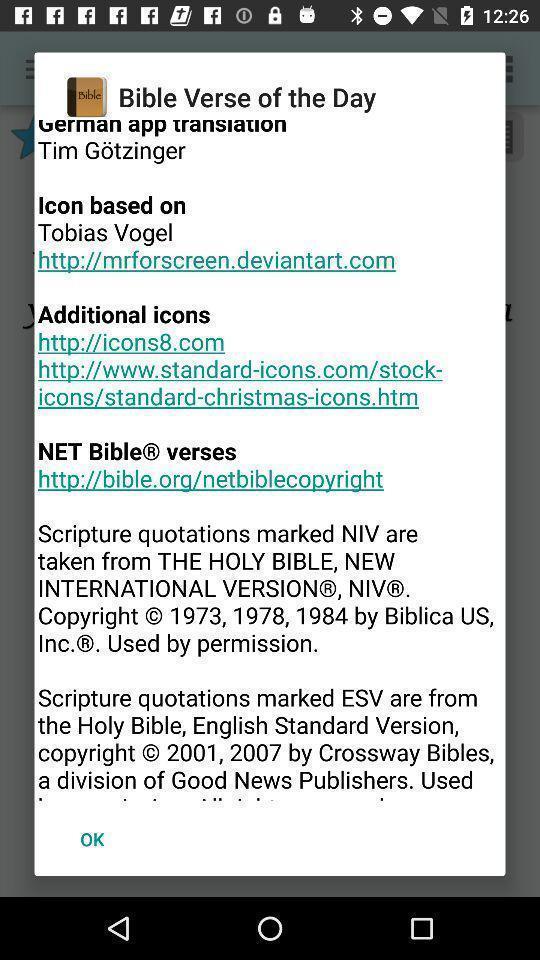Give me a summary of this screen capture. Pop-up showing details for a religious quotes based app. 